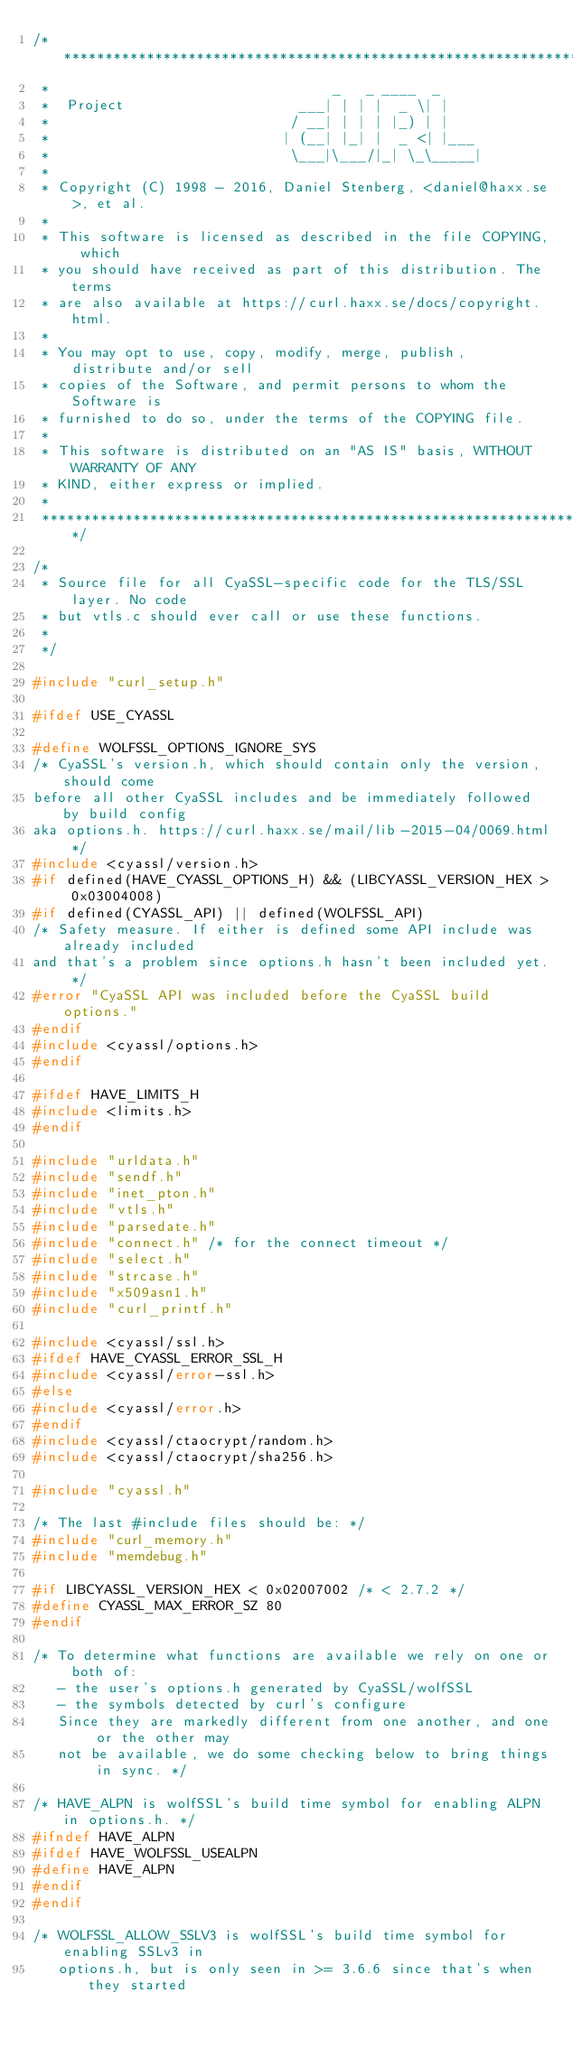Convert code to text. <code><loc_0><loc_0><loc_500><loc_500><_C_>/***************************************************************************
 *                                  _   _ ____  _
 *  Project                     ___| | | |  _ \| |
 *                             / __| | | | |_) | |
 *                            | (__| |_| |  _ <| |___
 *                             \___|\___/|_| \_\_____|
 *
 * Copyright (C) 1998 - 2016, Daniel Stenberg, <daniel@haxx.se>, et al.
 *
 * This software is licensed as described in the file COPYING, which
 * you should have received as part of this distribution. The terms
 * are also available at https://curl.haxx.se/docs/copyright.html.
 *
 * You may opt to use, copy, modify, merge, publish, distribute and/or sell
 * copies of the Software, and permit persons to whom the Software is
 * furnished to do so, under the terms of the COPYING file.
 *
 * This software is distributed on an "AS IS" basis, WITHOUT WARRANTY OF ANY
 * KIND, either express or implied.
 *
 ***************************************************************************/

/*
 * Source file for all CyaSSL-specific code for the TLS/SSL layer. No code
 * but vtls.c should ever call or use these functions.
 *
 */

#include "curl_setup.h"

#ifdef USE_CYASSL

#define WOLFSSL_OPTIONS_IGNORE_SYS
/* CyaSSL's version.h, which should contain only the version, should come
before all other CyaSSL includes and be immediately followed by build config
aka options.h. https://curl.haxx.se/mail/lib-2015-04/0069.html */
#include <cyassl/version.h>
#if defined(HAVE_CYASSL_OPTIONS_H) && (LIBCYASSL_VERSION_HEX > 0x03004008)
#if defined(CYASSL_API) || defined(WOLFSSL_API)
/* Safety measure. If either is defined some API include was already included
and that's a problem since options.h hasn't been included yet. */
#error "CyaSSL API was included before the CyaSSL build options."
#endif
#include <cyassl/options.h>
#endif

#ifdef HAVE_LIMITS_H
#include <limits.h>
#endif

#include "urldata.h"
#include "sendf.h"
#include "inet_pton.h"
#include "vtls.h"
#include "parsedate.h"
#include "connect.h" /* for the connect timeout */
#include "select.h"
#include "strcase.h"
#include "x509asn1.h"
#include "curl_printf.h"

#include <cyassl/ssl.h>
#ifdef HAVE_CYASSL_ERROR_SSL_H
#include <cyassl/error-ssl.h>
#else
#include <cyassl/error.h>
#endif
#include <cyassl/ctaocrypt/random.h>
#include <cyassl/ctaocrypt/sha256.h>

#include "cyassl.h"

/* The last #include files should be: */
#include "curl_memory.h"
#include "memdebug.h"

#if LIBCYASSL_VERSION_HEX < 0x02007002 /* < 2.7.2 */
#define CYASSL_MAX_ERROR_SZ 80
#endif

/* To determine what functions are available we rely on one or both of:
   - the user's options.h generated by CyaSSL/wolfSSL
   - the symbols detected by curl's configure
   Since they are markedly different from one another, and one or the other may
   not be available, we do some checking below to bring things in sync. */

/* HAVE_ALPN is wolfSSL's build time symbol for enabling ALPN in options.h. */
#ifndef HAVE_ALPN
#ifdef HAVE_WOLFSSL_USEALPN
#define HAVE_ALPN
#endif
#endif

/* WOLFSSL_ALLOW_SSLV3 is wolfSSL's build time symbol for enabling SSLv3 in
   options.h, but is only seen in >= 3.6.6 since that's when they started</code> 